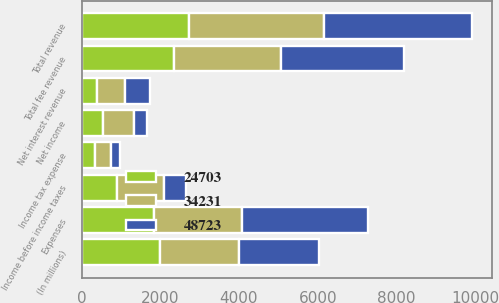Convert chart to OTSL. <chart><loc_0><loc_0><loc_500><loc_500><stacked_bar_chart><ecel><fcel>(In millions)<fcel>Total fee revenue<fcel>Net interest revenue<fcel>Total revenue<fcel>Expenses<fcel>Income before income taxes<fcel>Income tax expense<fcel>Net income<nl><fcel>48723<fcel>2008<fcel>3129<fcel>632<fcel>3761<fcel>3203<fcel>558<fcel>215<fcel>343<nl><fcel>34231<fcel>2007<fcel>2707<fcel>713<fcel>3420<fcel>2233<fcel>1187<fcel>415<fcel>772<nl><fcel>24703<fcel>2006<fcel>2349<fcel>392<fcel>2741<fcel>1840<fcel>901<fcel>346<fcel>555<nl></chart> 